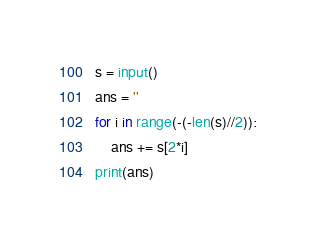<code> <loc_0><loc_0><loc_500><loc_500><_Python_>s = input()
ans = ''
for i in range(-(-len(s)//2)):
    ans += s[2*i]
print(ans)</code> 